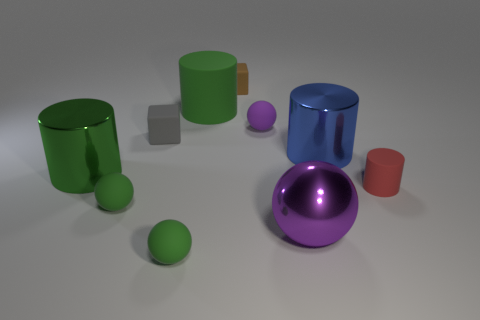Subtract all gray balls. How many green cylinders are left? 2 Subtract all small purple matte spheres. How many spheres are left? 3 Subtract 1 spheres. How many spheres are left? 3 Subtract all blue cylinders. How many cylinders are left? 3 Subtract all spheres. How many objects are left? 6 Subtract 0 cyan blocks. How many objects are left? 10 Subtract all brown cylinders. Subtract all yellow cubes. How many cylinders are left? 4 Subtract all tiny yellow spheres. Subtract all purple metal spheres. How many objects are left? 9 Add 6 large metal cylinders. How many large metal cylinders are left? 8 Add 1 gray things. How many gray things exist? 2 